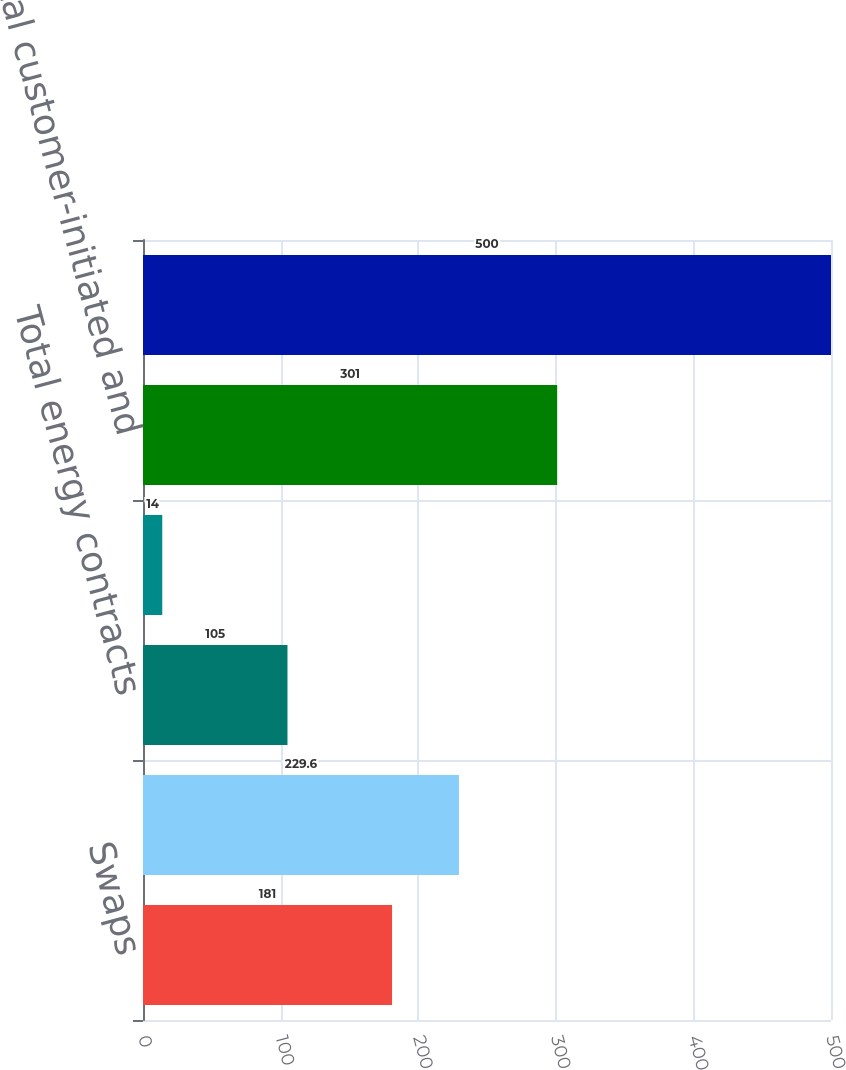Convert chart to OTSL. <chart><loc_0><loc_0><loc_500><loc_500><bar_chart><fcel>Swaps<fcel>Total interest rate contracts<fcel>Total energy contracts<fcel>Spot forwards options and<fcel>Total customer-initiated and<fcel>Total gross derivatives<nl><fcel>181<fcel>229.6<fcel>105<fcel>14<fcel>301<fcel>500<nl></chart> 